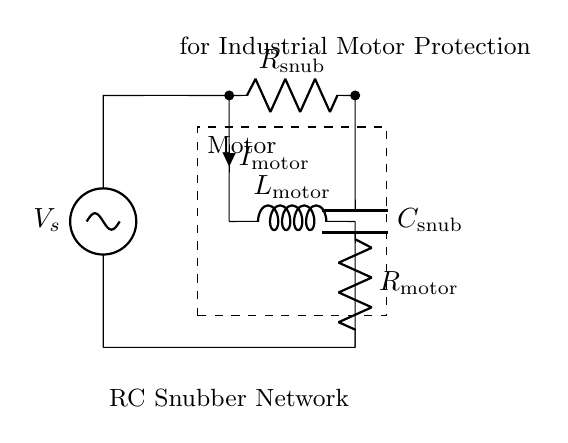What is the component in series with the capacitor? The component in series with the capacitor is the resistor, which is labeled as R snub. This means that the resistor is connected directly to the capacitor and forms a series connection.
Answer: R snub What is the current flowing through the motor labeled as? The current flowing through the motor is labeled as I motor. This is indicated in the circuit, showing the direction and point of measurement for the motor's current.
Answer: I motor What does the L component represent in this circuit? The L component represents the inductance of the motor, which is labeled as L motor. This shows that it stores energy in a magnetic field when current flows through it.
Answer: L motor What is the main purpose of the RC snubber network? The main purpose of the RC snubber network is to protect the industrial motor from voltage spikes or transients. It helps in suppressing these harmful voltage effects, which can damage the motor over time.
Answer: Protect industrial motor How does the RC snubber affect the operation of the motor? The RC snubber smoothens the voltage and current transitions to and from the motor, reducing electromagnetic interference and mechanical stress. This results in more reliable motor operation and extends its lifespan.
Answer: Smooths voltage transitions What type of circuit is depicted here? The circuit is an RC snubber network, typically used in conjunction with inductive loads like motors for transient suppression. The combination of the resistor and capacitor is specific to RC circuits designed to absorb voltage spikes.
Answer: RC snubber network 